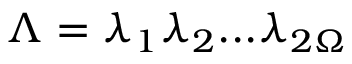Convert formula to latex. <formula><loc_0><loc_0><loc_500><loc_500>\Lambda = \lambda _ { 1 } \lambda _ { 2 } \dots \lambda _ { 2 \Omega }</formula> 